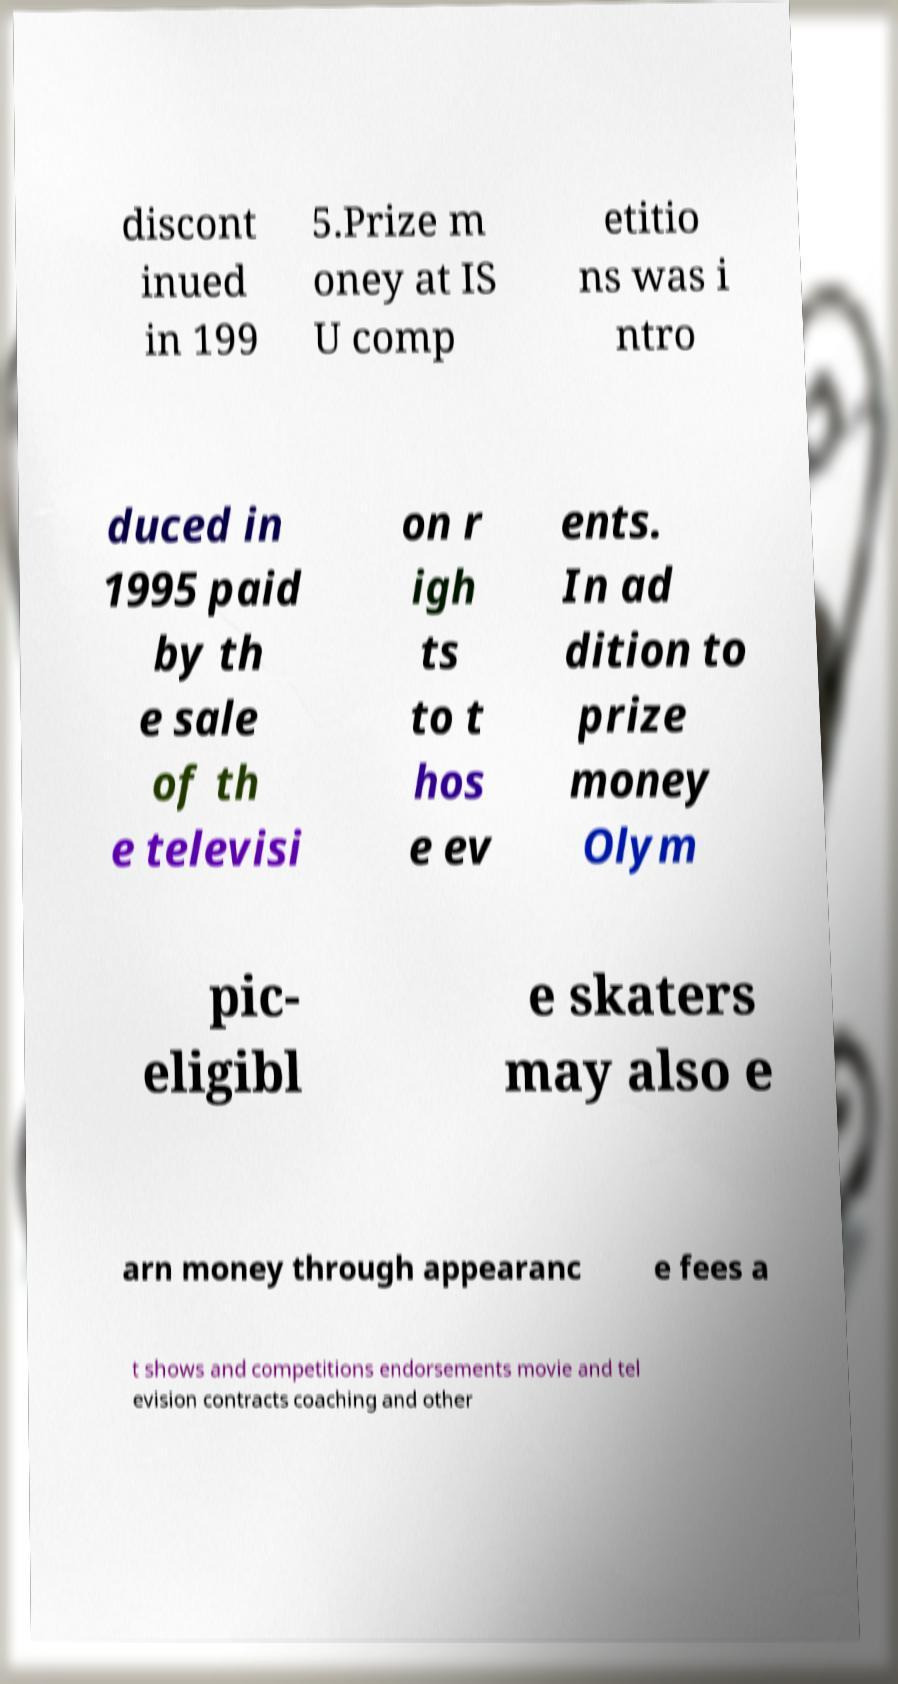There's text embedded in this image that I need extracted. Can you transcribe it verbatim? discont inued in 199 5.Prize m oney at IS U comp etitio ns was i ntro duced in 1995 paid by th e sale of th e televisi on r igh ts to t hos e ev ents. In ad dition to prize money Olym pic- eligibl e skaters may also e arn money through appearanc e fees a t shows and competitions endorsements movie and tel evision contracts coaching and other 